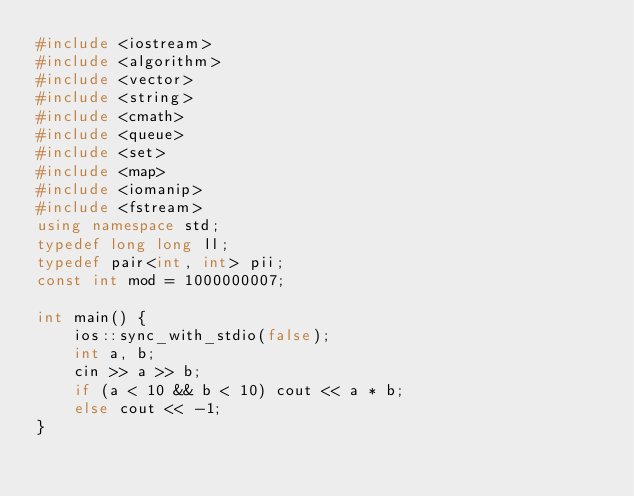Convert code to text. <code><loc_0><loc_0><loc_500><loc_500><_C++_>#include <iostream>
#include <algorithm>
#include <vector>
#include <string>
#include <cmath>
#include <queue>
#include <set>
#include <map>
#include <iomanip>
#include <fstream>
using namespace std;
typedef long long ll;
typedef pair<int, int> pii;
const int mod = 1000000007;

int main() {
    ios::sync_with_stdio(false);
    int a, b;
    cin >> a >> b;
    if (a < 10 && b < 10) cout << a * b;
    else cout << -1;
}
</code> 